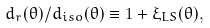Convert formula to latex. <formula><loc_0><loc_0><loc_500><loc_500>d _ { r } ( \theta ) / d _ { i s o } ( \theta ) \equiv 1 + \xi _ { L S } ( \theta ) ,</formula> 